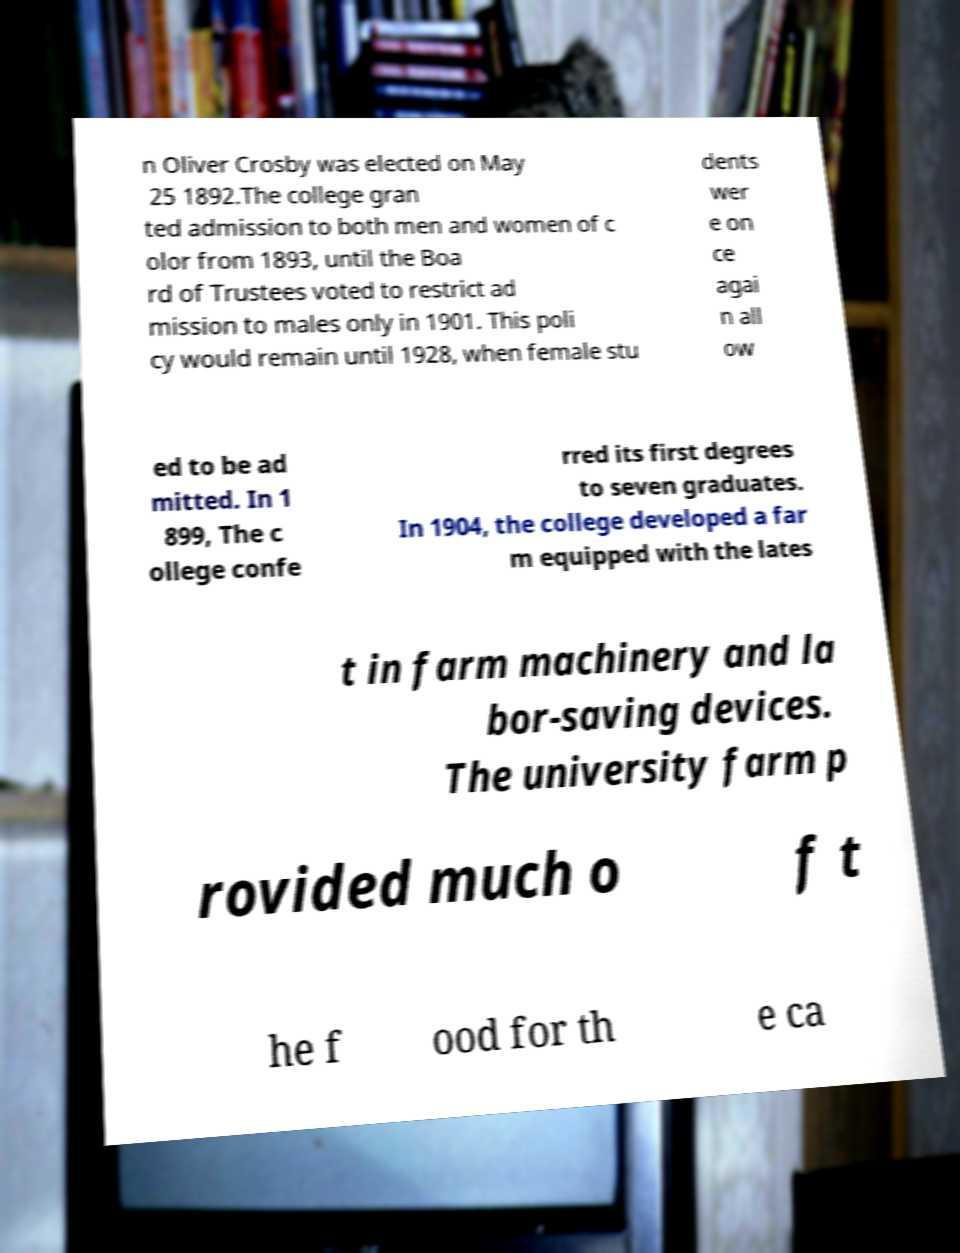Can you accurately transcribe the text from the provided image for me? n Oliver Crosby was elected on May 25 1892.The college gran ted admission to both men and women of c olor from 1893, until the Boa rd of Trustees voted to restrict ad mission to males only in 1901. This poli cy would remain until 1928, when female stu dents wer e on ce agai n all ow ed to be ad mitted. In 1 899, The c ollege confe rred its first degrees to seven graduates. In 1904, the college developed a far m equipped with the lates t in farm machinery and la bor-saving devices. The university farm p rovided much o f t he f ood for th e ca 